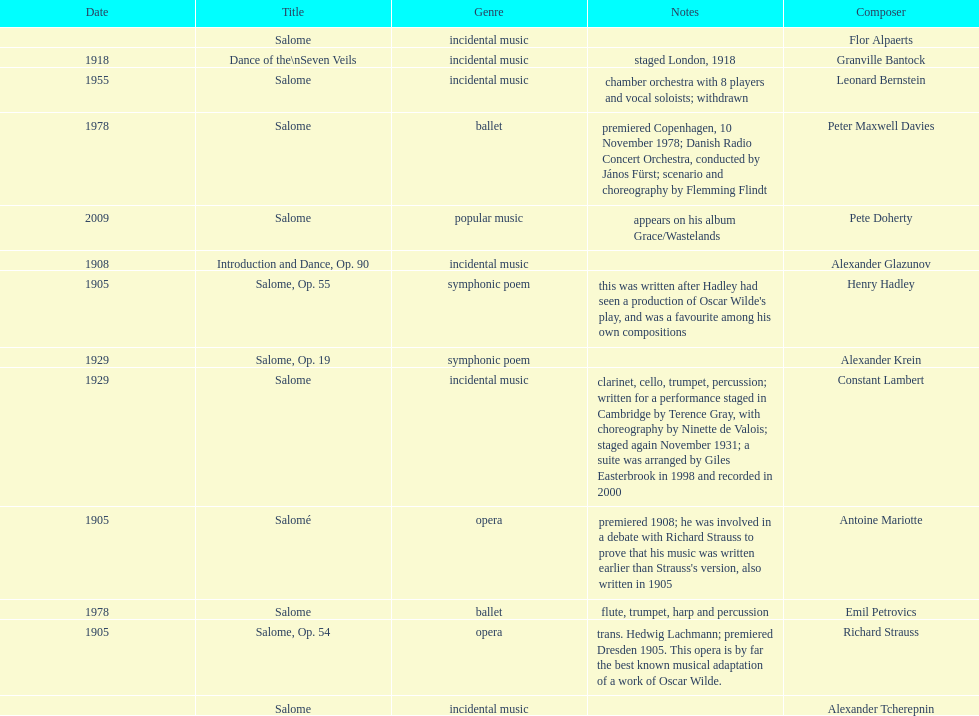Who is next on the list after alexander krein? Constant Lambert. 